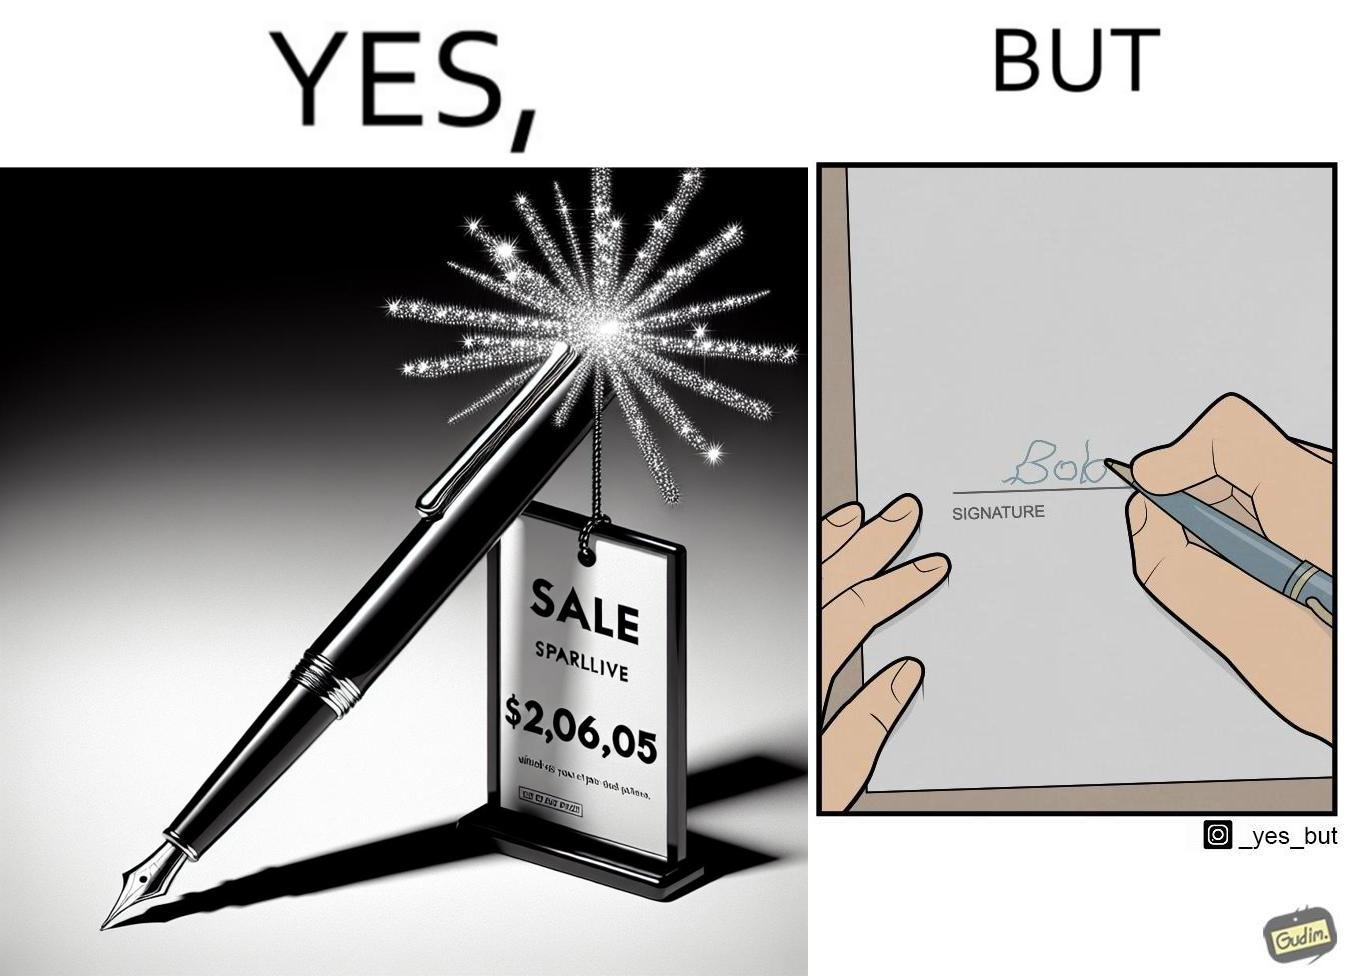Describe the contrast between the left and right parts of this image. In the left part of the image: a new sparkling pen at some sale priced at around $2,065.00 In the right part of the image: someone with not so good handwriting giving his signature at some paper 